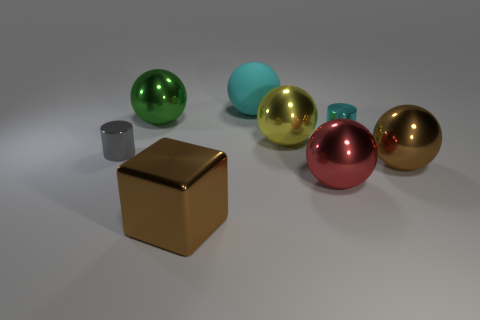There is a large object that is the same color as the large metallic block; what shape is it?
Offer a terse response. Sphere. Is there a cylinder of the same color as the large metal block?
Provide a short and direct response. No. Are any small red metallic blocks visible?
Offer a terse response. No. There is a tiny cylinder that is right of the gray metallic object; what color is it?
Make the answer very short. Cyan. Do the yellow object and the brown thing behind the large block have the same size?
Your response must be concise. Yes. There is a metal thing that is both on the left side of the small cyan object and behind the yellow object; what is its size?
Make the answer very short. Large. Are there any large red balls that have the same material as the small cyan thing?
Provide a succinct answer. Yes. What shape is the tiny cyan metallic object?
Your response must be concise. Cylinder. Do the cyan shiny cylinder and the brown metal ball have the same size?
Provide a short and direct response. No. How many other objects are the same shape as the big yellow metallic thing?
Offer a terse response. 4. 